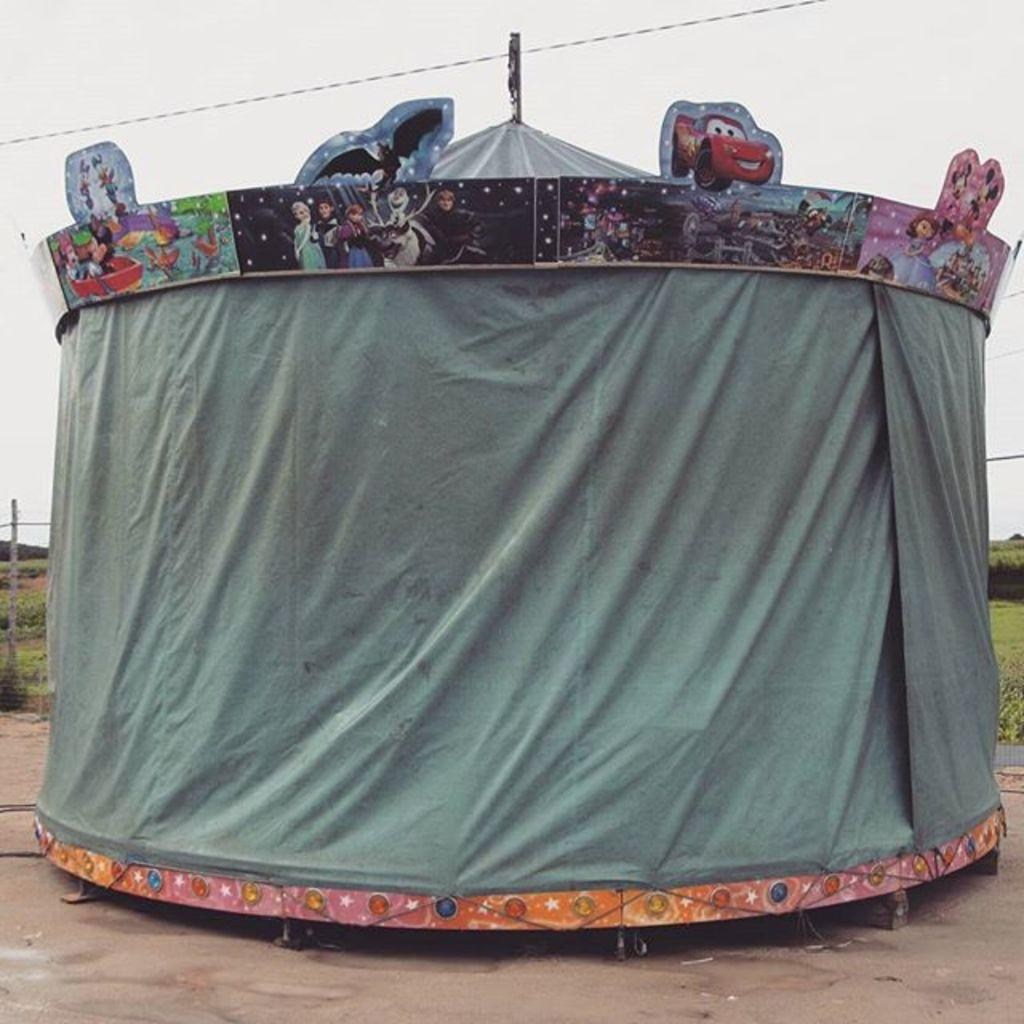What structure can be seen in the image? There is a tent in the image. What other objects are present in the image? There are boards and a wire visible in the image. What can be seen in the background of the image? There is grass, a pole, plants, and the sky visible in the background of the image. What type of prose is being recited by the plants in the background of the image? There are no plants reciting prose in the image; the plants are stationary and not engaged in any activity. 